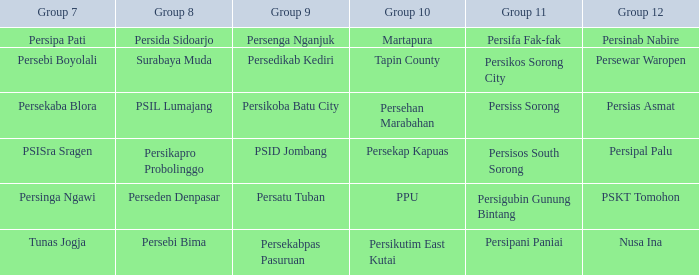When persikos sorong city participated in group 11, who was in group 7? Persebi Boyolali. 